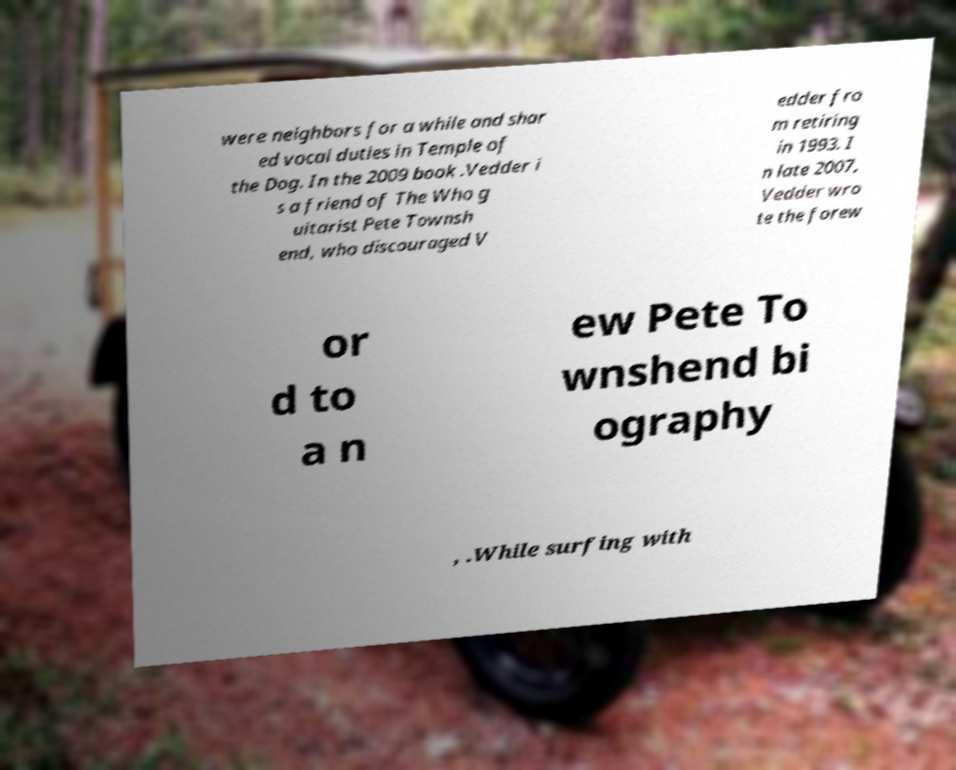For documentation purposes, I need the text within this image transcribed. Could you provide that? were neighbors for a while and shar ed vocal duties in Temple of the Dog. In the 2009 book .Vedder i s a friend of The Who g uitarist Pete Townsh end, who discouraged V edder fro m retiring in 1993. I n late 2007, Vedder wro te the forew or d to a n ew Pete To wnshend bi ography , .While surfing with 